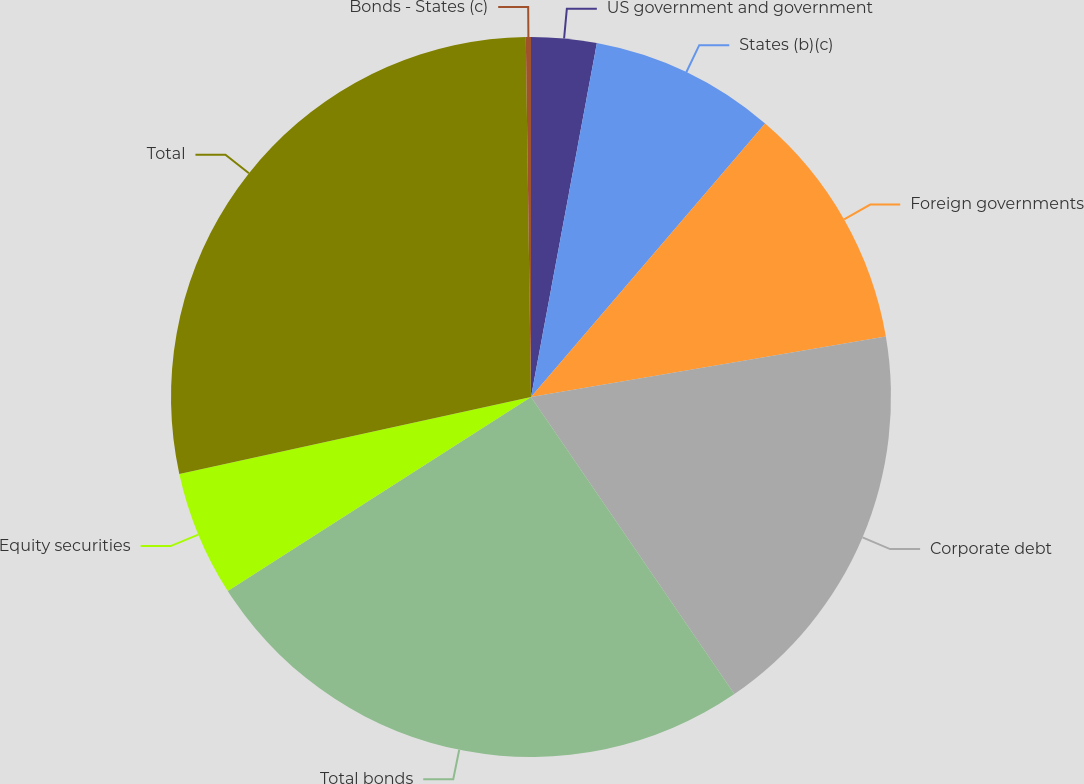Convert chart to OTSL. <chart><loc_0><loc_0><loc_500><loc_500><pie_chart><fcel>US government and government<fcel>States (b)(c)<fcel>Foreign governments<fcel>Corporate debt<fcel>Total bonds<fcel>Equity securities<fcel>Total<fcel>Bonds - States (c)<nl><fcel>2.93%<fcel>8.34%<fcel>11.04%<fcel>18.14%<fcel>25.5%<fcel>5.63%<fcel>28.2%<fcel>0.23%<nl></chart> 